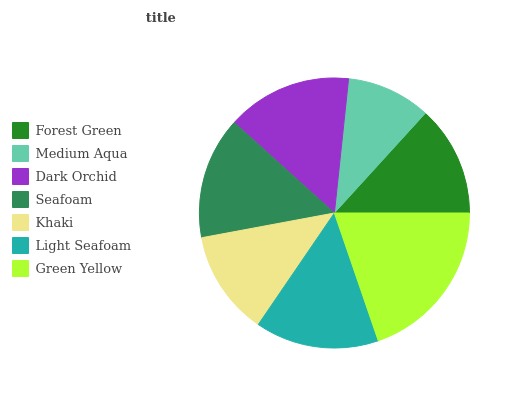Is Medium Aqua the minimum?
Answer yes or no. Yes. Is Green Yellow the maximum?
Answer yes or no. Yes. Is Dark Orchid the minimum?
Answer yes or no. No. Is Dark Orchid the maximum?
Answer yes or no. No. Is Dark Orchid greater than Medium Aqua?
Answer yes or no. Yes. Is Medium Aqua less than Dark Orchid?
Answer yes or no. Yes. Is Medium Aqua greater than Dark Orchid?
Answer yes or no. No. Is Dark Orchid less than Medium Aqua?
Answer yes or no. No. Is Seafoam the high median?
Answer yes or no. Yes. Is Seafoam the low median?
Answer yes or no. Yes. Is Green Yellow the high median?
Answer yes or no. No. Is Green Yellow the low median?
Answer yes or no. No. 